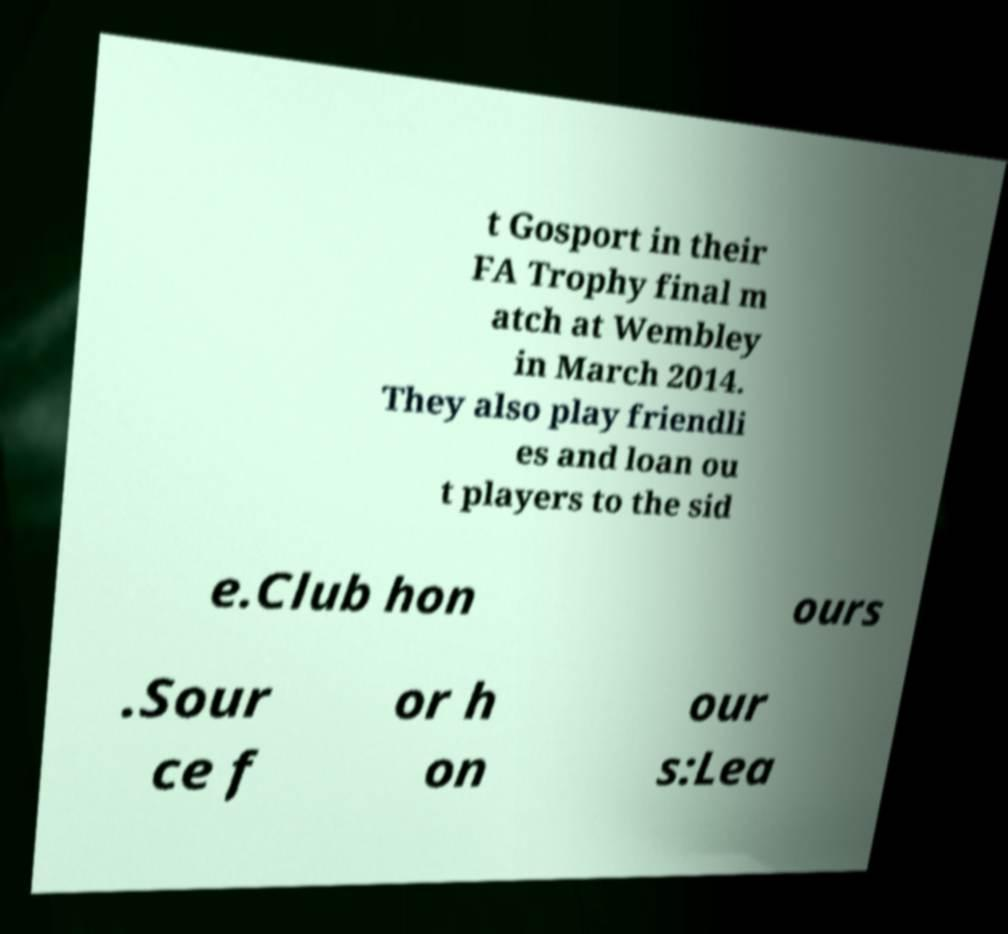Could you assist in decoding the text presented in this image and type it out clearly? t Gosport in their FA Trophy final m atch at Wembley in March 2014. They also play friendli es and loan ou t players to the sid e.Club hon ours .Sour ce f or h on our s:Lea 